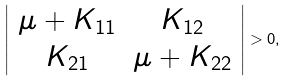Convert formula to latex. <formula><loc_0><loc_0><loc_500><loc_500>\left | \begin{array} { c c } \mu + K _ { 1 1 } & K _ { 1 2 } \\ K _ { 2 1 } & \mu + K _ { 2 2 } \end{array} \right | > 0 ,</formula> 